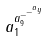<formula> <loc_0><loc_0><loc_500><loc_500>a _ { 1 } ^ { a _ { 9 } ^ { - ^ { - ^ { a _ { y } } } } }</formula> 